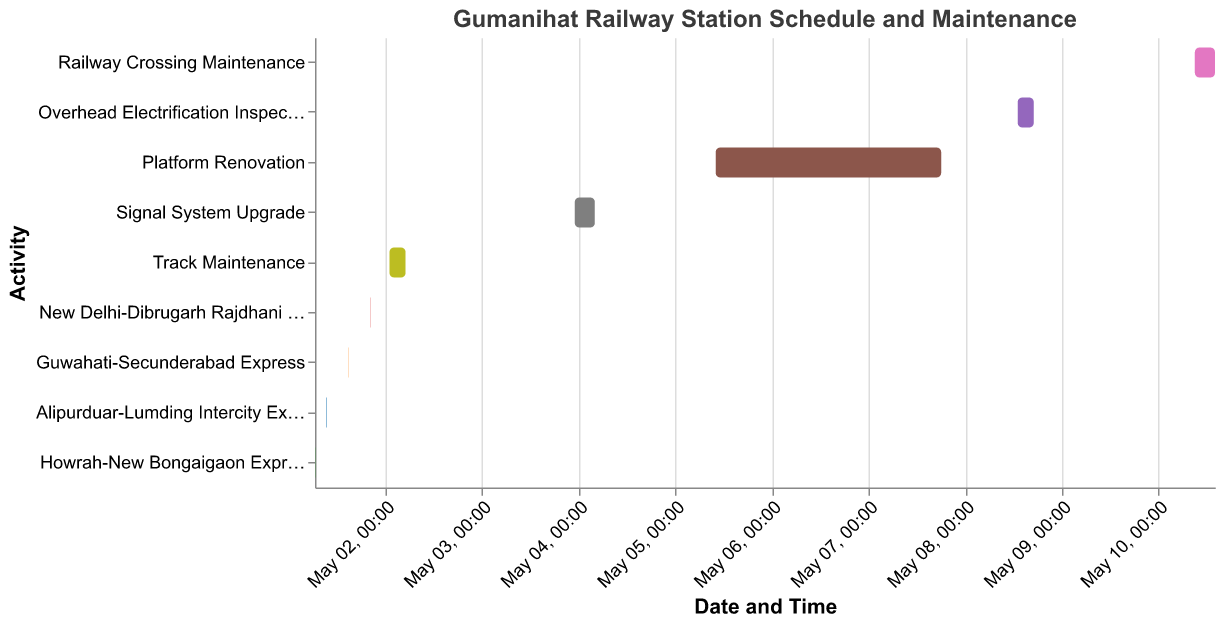What is the first train scheduled on May 1st? The first train scheduled based on the start time is "Howrah-New Bongaigaon Express," which starts at 06:30 on May 1st.
Answer: Howrah-New Bongaigaon Express How many maintenance activities are shown in the schedule? The maintenance activities listed are: Track Maintenance, Signal System Upgrade, Platform Renovation, Overhead Electrification Inspection, and Railway Crossing Maintenance.
Answer: 5 What is the duration of Platform Renovation? Platform Renovation starts on May 5th at 10:00 and ends on May 7th at 18:00. To calculate the duration, we find the difference between the start and end times: 2 days and 8 hours, which is 56 hours.
Answer: 56 hours Which task occurs after Track Maintenance? By referring to the dates and times, the next task after Track Maintenance is Signal System Upgrade, which starts on May 3rd at 23:00.
Answer: Signal System Upgrade What is the shortest train stop time and which train is it for? By comparing the duration of each train stop, the shortest stop time is for each train, lasting 5 minutes. For example, the "Howrah-New Bongaigaon Express" stops from 06:30 to 06:35.
Answer: 5 minutes (any train) Which maintenance task takes the longest time? The longest maintenance task is Platform Renovation, which spans from May 5th at 10:00 to May 7th at 18:00, a total of 56 hours.
Answer: Platform Renovation How do the start and end times of the "Guwahati-Secunderabad Express" compare with the "New Delhi-Dibrugarh Rajdhani Express"? The "Guwahati-Secunderabad Express" starts at 14:45 on May 1st and ends at 14:50, while the "New Delhi-Dibrugarh Rajdhani Express" starts at 20:10 and ends at 20:15 on the same day. The former occurs earlier than the latter.
Answer: Guwahati-Secunderabad Express is earlier How long is the overlap between Overhead Electrification Inspection and Platform Renovation, if any? Platform Renovation ends on May 7th at 18:00, while Overhead Electrification Inspection starts on May 8th at 13:00. They do not overlap.
Answer: No overlap What's the total duration of maintenance tasks scheduled up to May 8th? Summing up the durations of individual tasks: Track Maintenance (4 hours), Signal System Upgrade (5 hours), Platform Renovation (56 hours), and Overhead Electrification Inspection (4 hours) = 69 hours in total.
Answer: 69 hours 